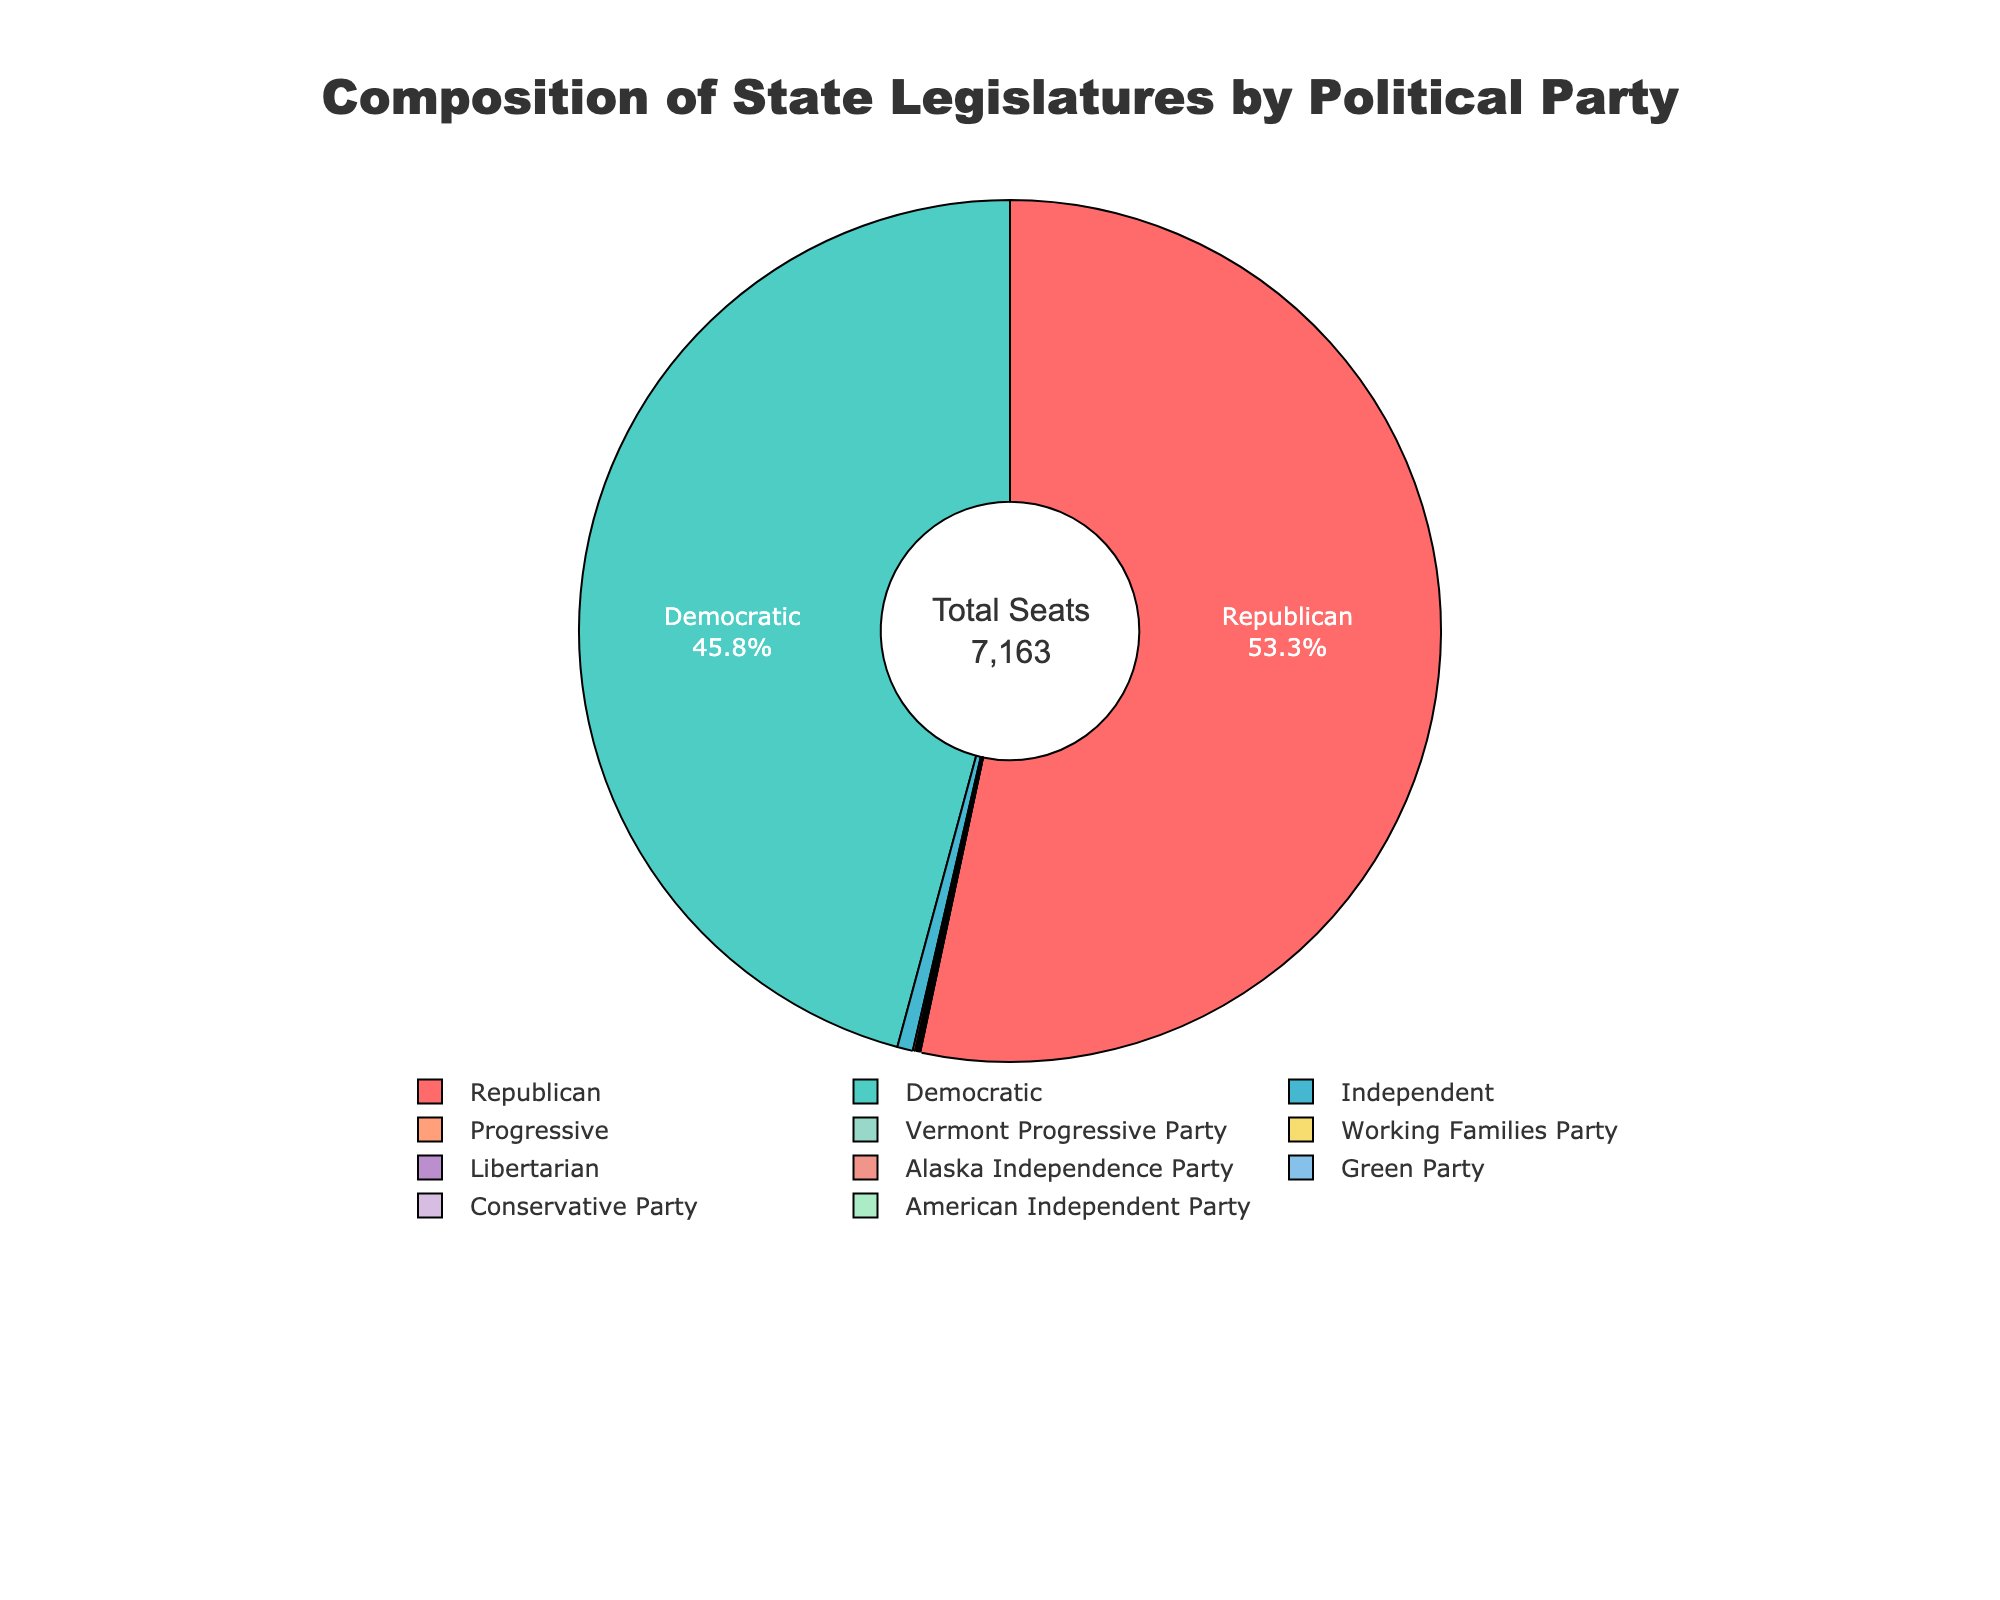What's the percentage of seats held by Republican legislators? To find the percentage, we need to divide the number of Republican seats by the total number of seats and then multiply by 100. Total seats are 3821 (Republican) + 3280 (Democratic) + 42 (Independent) + 2 (Libertarian) + 6 (Progressive) + 3 (Working Families Party) + 5 (Vermont Progressive Party) + 1 (Alaska Independence Party) + 1 (Green Party) + 1 (Conservative Party) + 1 (American Independent Party) = 9163. The percentage is (3821 / 9163) * 100 = 41.7%
Answer: 41.7% How many more seats do Republicans have compared to Democrats? To find the difference, subtract the number of Democratic seats from the number of Republican seats. Republican seats are 3821 and Democratic seats are 3280. The difference is 3821 - 3280 = 541 seats
Answer: 541 Which two political parties have the smallest number of seats, and how many seats are there combined? By looking at the chart, the Alaska Independence Party, Green Party, Conservative Party, and American Independent Party each have 1 seat. The two smallest are any of these two parties, each contributing 1 seat for a combined total.
Answer: 1 + 1 = 2 What fraction of the legislature is composed of parties other than Republican and Democratic? To find this, sum the seats of all non-Republican and non-Democratic parties and then divide by the total number of seats. Total non-Republican and non-Democratic seats: 42 (Independent) + 2 (Libertarian) + 6 (Progressive) + 3 (Working Families Party) + 5 (Vermont Progressive Party) + 1 (Alaska Independence Party) + 1 (Green Party) + 1 (Conservative Party) + 1 (American Independent Party) = 62. Fraction = 62 / 9163 ≈ 0.0068
Answer: 0.0068 What is the combined percentage of seats held by Independent, Libertarian, and Progressive parties? To find this, sum up the seats and then divide by the total number of seats and multiply by 100. Combined seats = 42 (Independent) + 2 (Libertarian) + 6 (Progressive) = 50. Combined percentage = (50 / 9163) * 100 ≈ 0.546%.
Answer: 0.546% Compare the total number of seats held by minor parties (excluding Republicans and Democrats) to the total number of seats held by Democrats. Minor parties have 62 seats (as calculated before). Democrats have 3280. 3280 > 62, so Democrats hold significantly more seats.
Answer: Democrats hold significantly more seats What visual colors are used to represent the Republican and Democratic parties on the pie chart? In the pie chart, specific colors represent percentages, usually with distinctive colors for major parties. The description indicates custom colors starting with '#FF6B6B' for the largest or significant groups. Typically, red (#FF6B6B) represents Republicans and blue/green shades follows for others. Given the description, Republicans use red, Democrats use light blue/green (assuming proportional distribution).
Answer: Republicans: Red, Democrats: Light Blue/Green How does the number of seats for the Working Families Party compare to the Vermont Progressive Party's seats? The Working Families Party has 3 seats, while the Vermont Progressive Party has 5 seats. 3 < 5, thus, the Vermont Progressive Party has more seats.
Answer: Vermont Progressive Party has more seats Calculate the percentage of seats held by parties with fewer than 10 seats. Combine seats of groups with fewer than 10 seats and divide by total seats, then multiply by 100. Total for these groups: 42 + 2 + 6 + 3 + 5 + 1 + 1 + 1 + 1 = 62. Percentage = (62 / 9163) * 100 ≈ 0.676%.
Answer: 0.676% Which party ranks third in terms of the number of seats, and how many seats does it have? By visual inspection of sorted seat counts, Independent Party ranks after Republicans and Democrats with 42 seats
Answer: Independent Party with 42 seats 